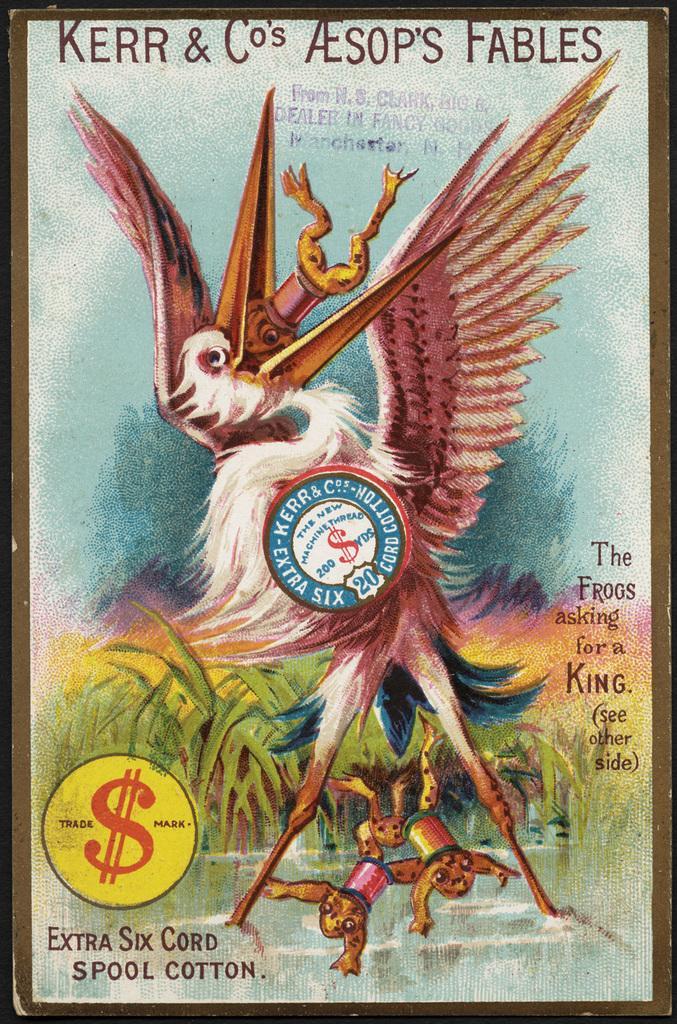Can you describe this image briefly? In this image I can see a poster and on it I can see depiction picture of animals, a bird and of grass. I can also see something is written on this poster and in the center I can see a logo. 